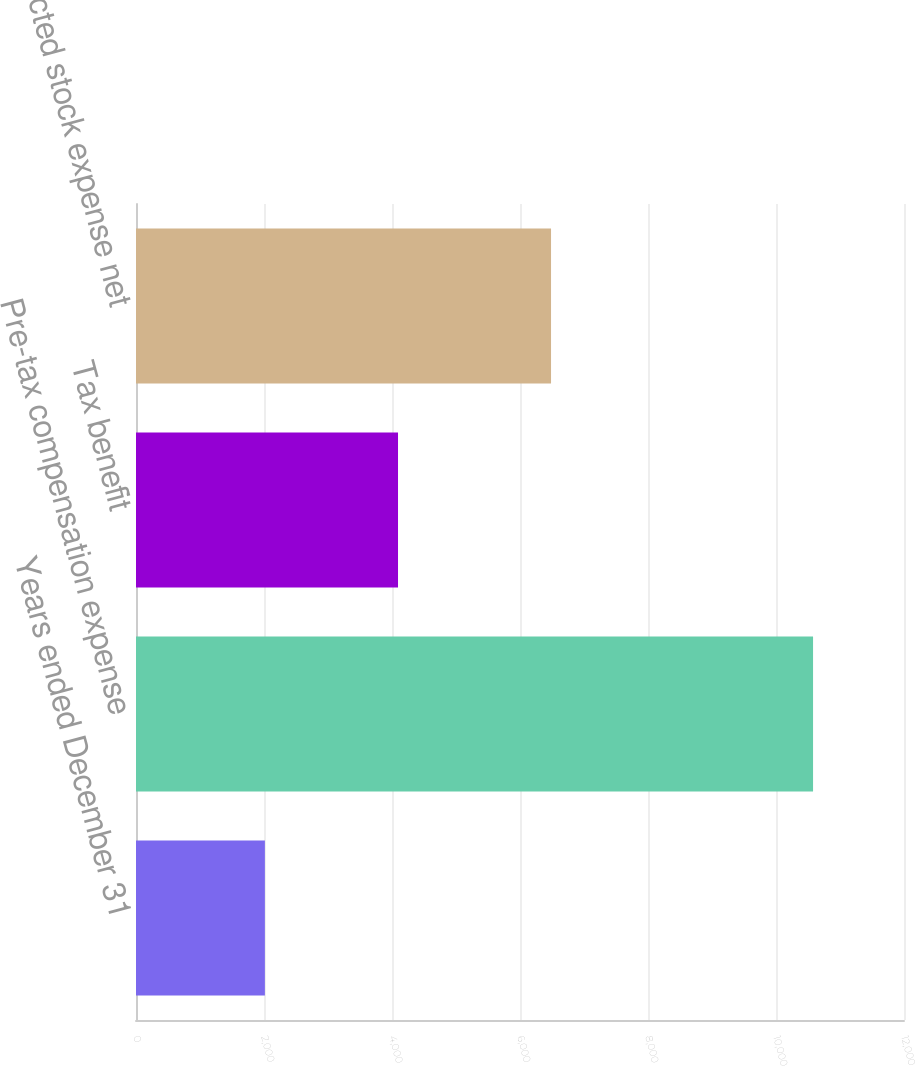Convert chart to OTSL. <chart><loc_0><loc_0><loc_500><loc_500><bar_chart><fcel>Years ended December 31<fcel>Pre-tax compensation expense<fcel>Tax benefit<fcel>Restricted stock expense net<nl><fcel>2014<fcel>10579<fcel>4094<fcel>6485<nl></chart> 